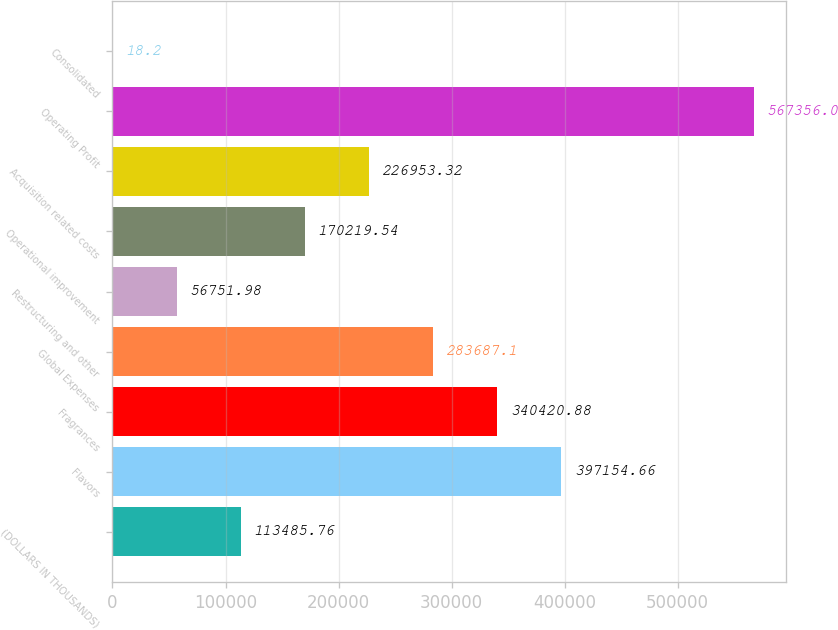<chart> <loc_0><loc_0><loc_500><loc_500><bar_chart><fcel>(DOLLARS IN THOUSANDS)<fcel>Flavors<fcel>Fragrances<fcel>Global Expenses<fcel>Restructuring and other<fcel>Operational improvement<fcel>Acquisition related costs<fcel>Operating Profit<fcel>Consolidated<nl><fcel>113486<fcel>397155<fcel>340421<fcel>283687<fcel>56752<fcel>170220<fcel>226953<fcel>567356<fcel>18.2<nl></chart> 